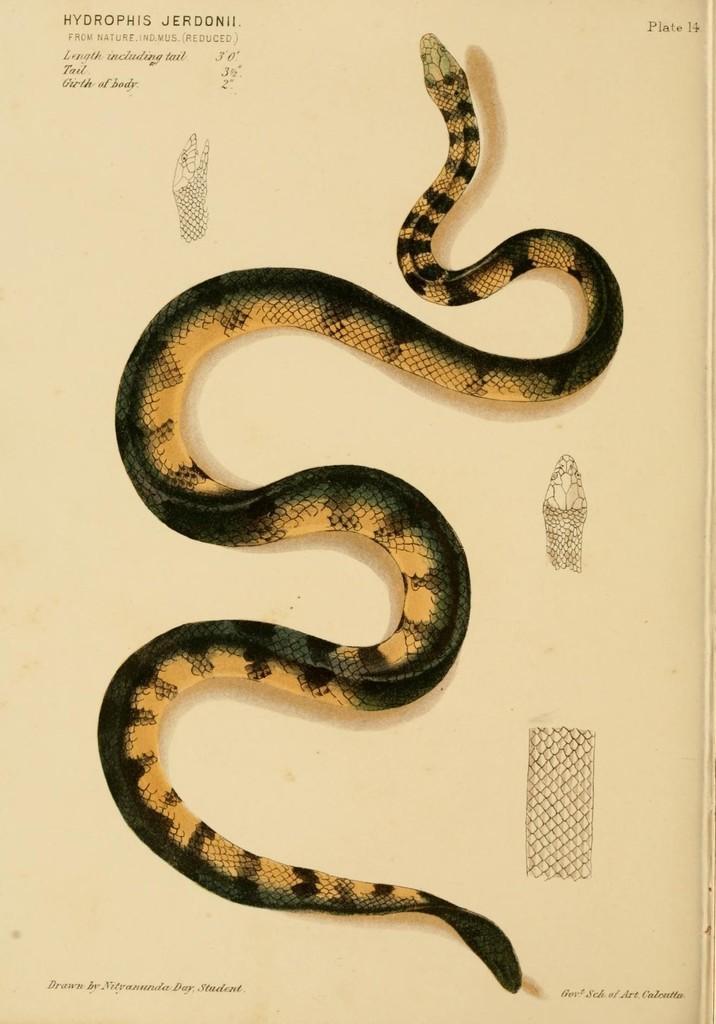How would you summarize this image in a sentence or two? This is a picture of a paper , where there are photos of a snake , and there are words and numbers on the paper. 